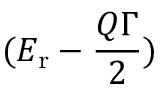Convert formula to latex. <formula><loc_0><loc_0><loc_500><loc_500>( E _ { r } - \frac { Q \Gamma } { 2 } )</formula> 